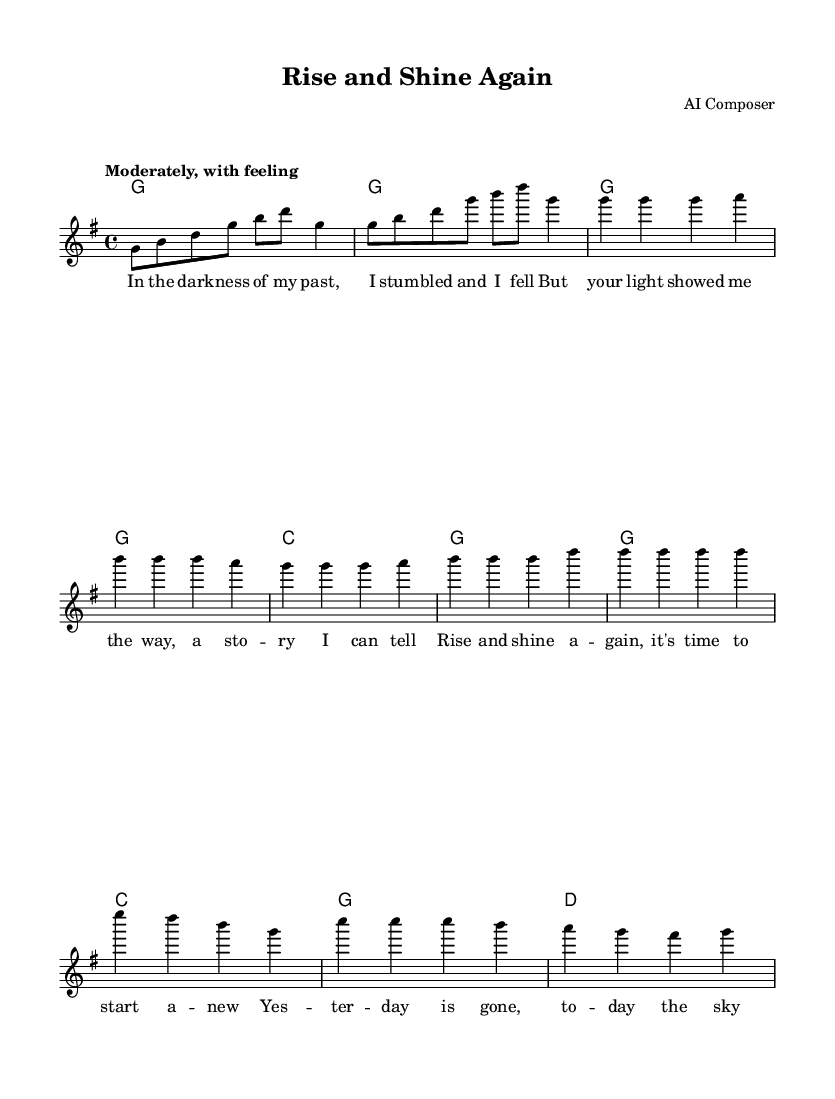What is the key signature of this music? The key signature is G major, which has one sharp (F#). This can be identified in the music sheet's key signature section at the beginning.
Answer: G major What is the time signature of this music? The time signature is 4/4, indicated at the beginning of the music sheet, which means there are four beats in each measure.
Answer: 4/4 What is the tempo marking for this song? The tempo marking is "Moderately, with feeling," which suggests a moderate pace to perform the piece. This is shown at the beginning of the sheet music.
Answer: Moderately, with feeling What is the first lyric line of the verse? The first lyric line of the verse is "In the dark -- ness of my past." This can be found under the melody notation within the lyrics section.
Answer: In the dark -- ness of my past How many measures are in the chorus? There are 4 measures in the chorus, as indicated by the grouping of the notes and their structure when looking at the score layout.
Answer: 4 How does the dynamics change in the chorus compared to the verse? The dynamics in the chorus likely become more uplifting or expansive, reflecting the song's theme of redemption; however, the exact dynamics are not specified, but one can infer a change from the context of the lyrics and the song's purpose.
Answer: Uplifting (assumed) Which chord is played during the chorus first? The first chord played during the chorus is G major, as indicated by the chord names specified above the melody notes during that section.
Answer: G 